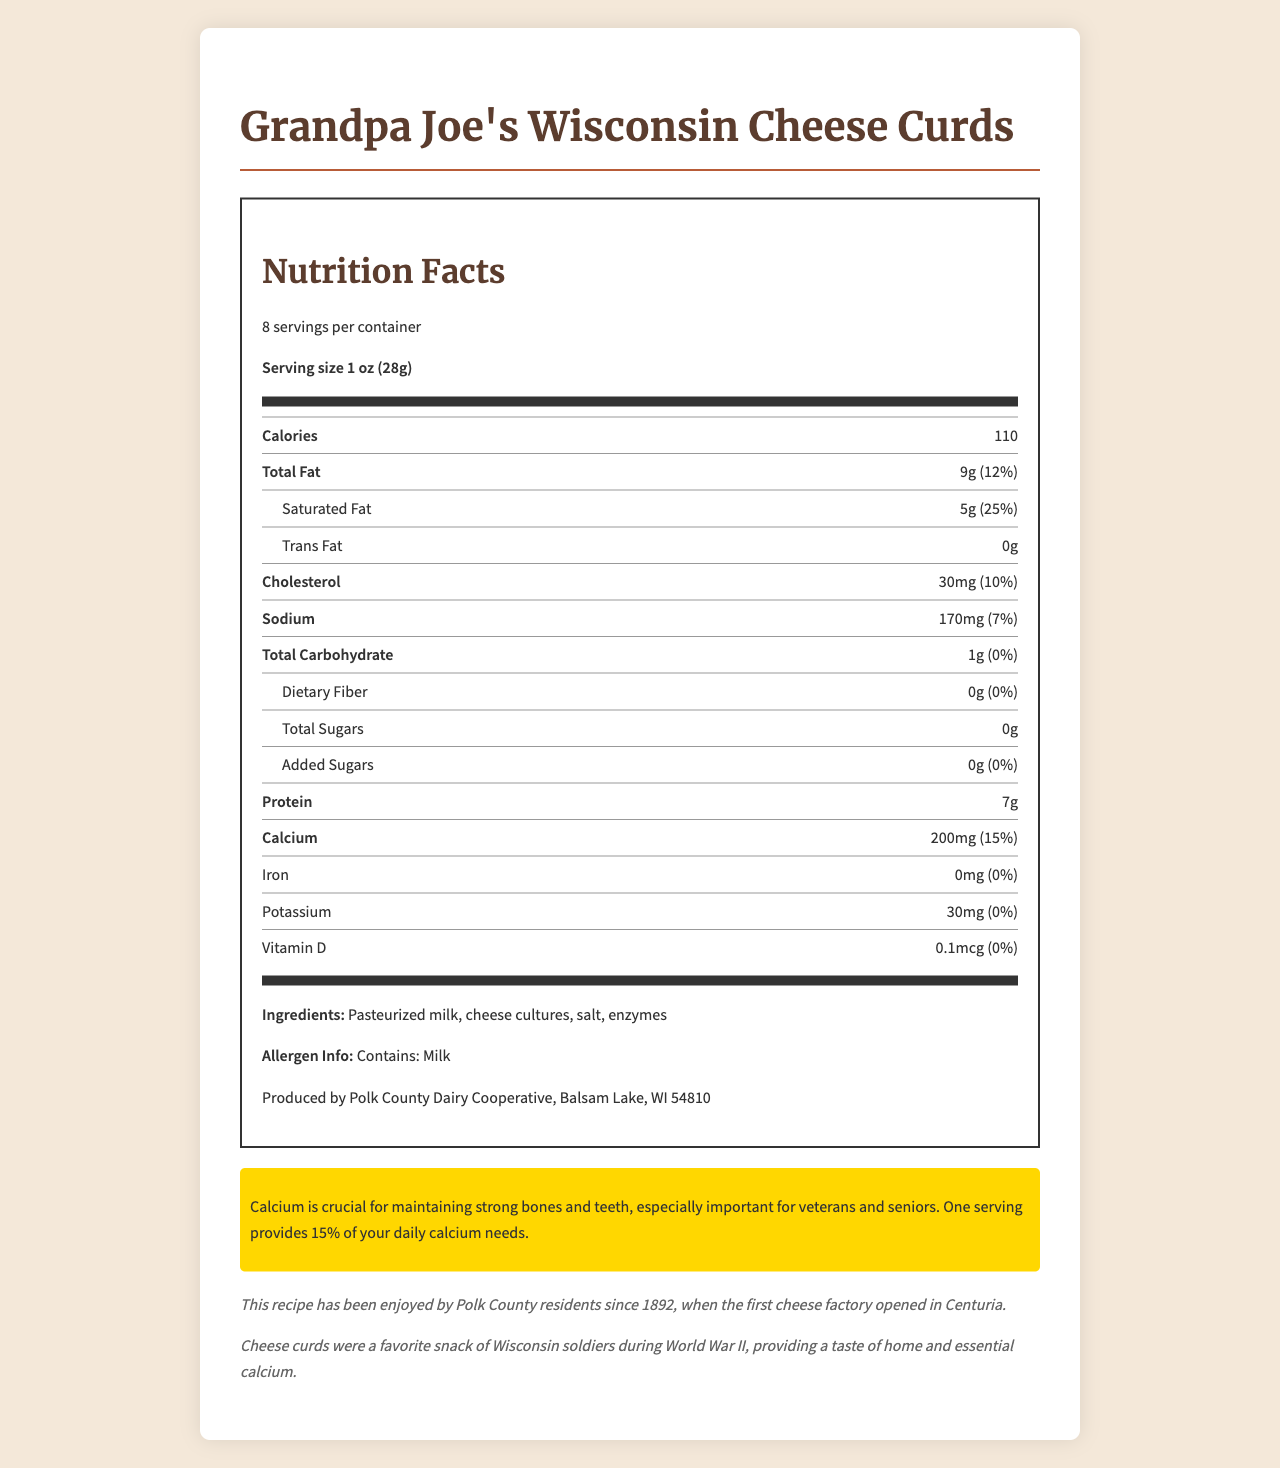What is the serving size of Grandpa Joe's Wisconsin Cheese Curds? The document states that the serving size is "1 oz (28g)".
Answer: 1 oz (28g) How many calories are in one serving of the cheese curds? According to the document, each serving contains 110 calories.
Answer: 110 calories What percentage of daily calcium needs does one serving provide? One serving provides 15% of the daily calcium needs, as highlighted in the document.
Answer: 15% How much protein is in a single serving? The nutrition facts label lists 7g of protein per serving.
Answer: 7g What is the historical significance of this cheese curds recipe? The document mentions that the recipe has historical roots dating back to 1892.
Answer: This recipe has been enjoyed by Polk County residents since 1892, when the first cheese factory opened in Centuria. Which nutrient has 0% daily value in the cheese curds? A. Calcium B. Dietary Fiber C. Potassium D. Cholesterol The document shows that dietary fiber has 0% of the daily value.
Answer: B. Dietary Fiber What is the amount of saturated fat per serving and its percent daily value? The document states that saturated fat is 5g per serving, which is 25% of the daily value.
Answer: 5g, 25% Where are these cheese curds produced? The manufacturer information in the document specifies this location.
Answer: Polk County Dairy Cooperative, Balsam Lake, WI 54810 How much calcium is in one serving of cheese curds? The document lists the calcium content as 200mg per serving.
Answer: 200mg Does the document state if the product contains any allergens? The allergen information indicates that the product contains milk.
Answer: Yes Why might cheese curds have been a popular snack for Wisconsin soldiers during WWII? The historical note mentions that cheese curds were favored by soldiers during WWII for these reasons.
Answer: Cheese curds provided a taste of home and essential calcium. What is the total fat content per serving and its percent daily value? According to the nutrition facts, the total fat content is 9g per serving, making up 12% of the daily value.
Answer: 9g, 12% How much sodium does one serving of cheese curds contain? The document indicates that there are 170mg of sodium per serving.
Answer: 170mg List the ingredients found in Grandpa Joe's Wisconsin Cheese Curds. The ingredients are clearly listed in the document.
Answer: Pasteurized milk, cheese cultures, salt, enzymes Did the first cheese factory in Polk County open in the early 19th century? The document states it opened in 1892, which is the late 19th century.
Answer: No Summarize the main idea of the document. The summary encapsulates the nutrition information, historical context, and health benefits mentioned in the document.
Answer: The document provides detailed nutrition facts for Grandpa Joe's Wisconsin Cheese Curds, highlighting their historical and cultural significance, particularly their calcium content, which is important for seniors and veterans. What is the percent daily value of iron in the cheese curds? The nutrition facts label indicates that the iron content is 0% of the daily value.
Answer: 0% How much vitamin D is in one serving? The document shows that each serving contains 0.1mcg of vitamin D.
Answer: 0.1mcg What protein source does the cheese curds use? The document does not specifically mention what the protein source is, only the protein content.
Answer: Cannot be determined 